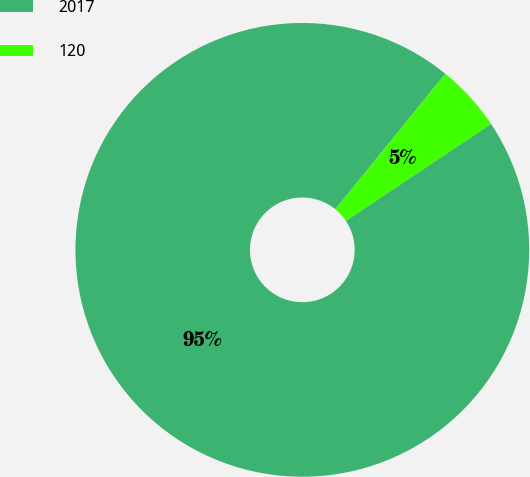<chart> <loc_0><loc_0><loc_500><loc_500><pie_chart><fcel>2017<fcel>120<nl><fcel>95.23%<fcel>4.77%<nl></chart> 